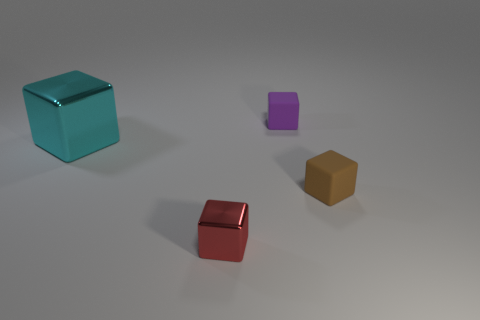There is a matte cube that is behind the metallic cube that is behind the small red cube; what size is it?
Give a very brief answer. Small. What is the material of the brown block that is the same size as the red block?
Provide a succinct answer. Rubber. How many other things are the same size as the cyan object?
Make the answer very short. 0. How many blocks are either purple objects or brown rubber objects?
Ensure brevity in your answer.  2. What is the block that is to the left of the shiny thing that is on the right side of the block that is left of the small metal thing made of?
Give a very brief answer. Metal. How many large cylinders have the same material as the small brown block?
Offer a terse response. 0. There is a metal thing behind the red cube; is its size the same as the brown rubber block?
Keep it short and to the point. No. There is a tiny thing that is made of the same material as the big cyan object; what color is it?
Make the answer very short. Red. Is there anything else that is the same size as the red cube?
Provide a short and direct response. Yes. There is a purple block; what number of rubber blocks are in front of it?
Provide a succinct answer. 1. 